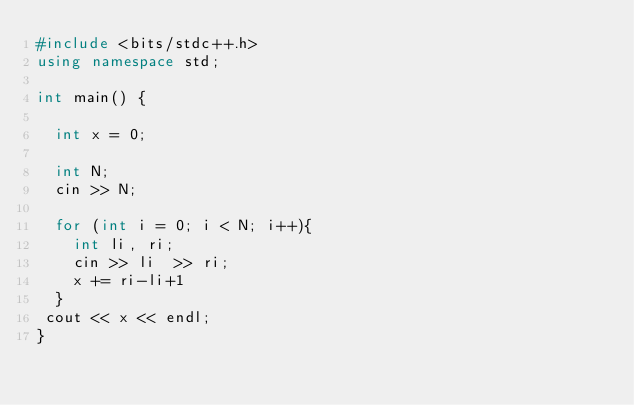Convert code to text. <code><loc_0><loc_0><loc_500><loc_500><_C++_>#include <bits/stdc++.h>
using namespace std;
 
int main() {

  int x = 0;
  
  int N;
  cin >> N;
  
  for (int i = 0; i < N; i++){
    int li, ri;
    cin >> li  >> ri;
    x += ri-li+1
  }
 cout << x << endl;
}</code> 